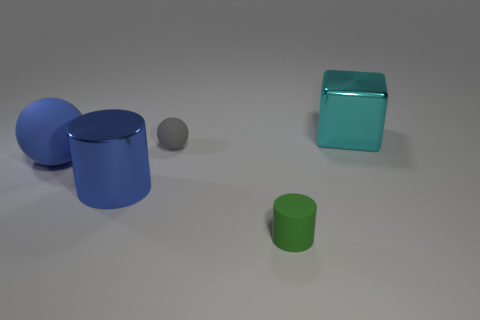What color is the big thing that is behind the tiny rubber object that is on the left side of the tiny rubber cylinder?
Keep it short and to the point. Cyan. Do the green cylinder and the large thing to the right of the rubber cylinder have the same material?
Offer a terse response. No. There is a cylinder that is left of the gray matte thing; what is it made of?
Ensure brevity in your answer.  Metal. Are there the same number of large cubes that are left of the large cyan cube and big rubber balls?
Your answer should be very brief. No. Is there anything else that has the same size as the rubber cylinder?
Provide a short and direct response. Yes. What material is the ball behind the ball in front of the tiny gray object?
Offer a terse response. Rubber. What shape is the large object that is both on the right side of the big ball and left of the cyan block?
Your response must be concise. Cylinder. There is a green matte object that is the same shape as the large blue metallic thing; what size is it?
Keep it short and to the point. Small. Is the number of rubber spheres that are behind the gray object less than the number of big cyan things?
Keep it short and to the point. Yes. There is a thing right of the green cylinder; how big is it?
Keep it short and to the point. Large. 